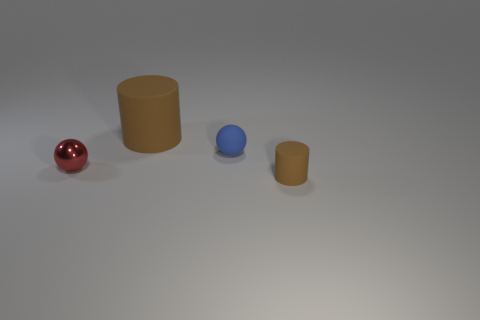Add 1 large rubber cylinders. How many objects exist? 5 Subtract all big rubber things. Subtract all small cylinders. How many objects are left? 2 Add 3 big rubber things. How many big rubber things are left? 4 Add 1 tiny red spheres. How many tiny red spheres exist? 2 Subtract 0 gray balls. How many objects are left? 4 